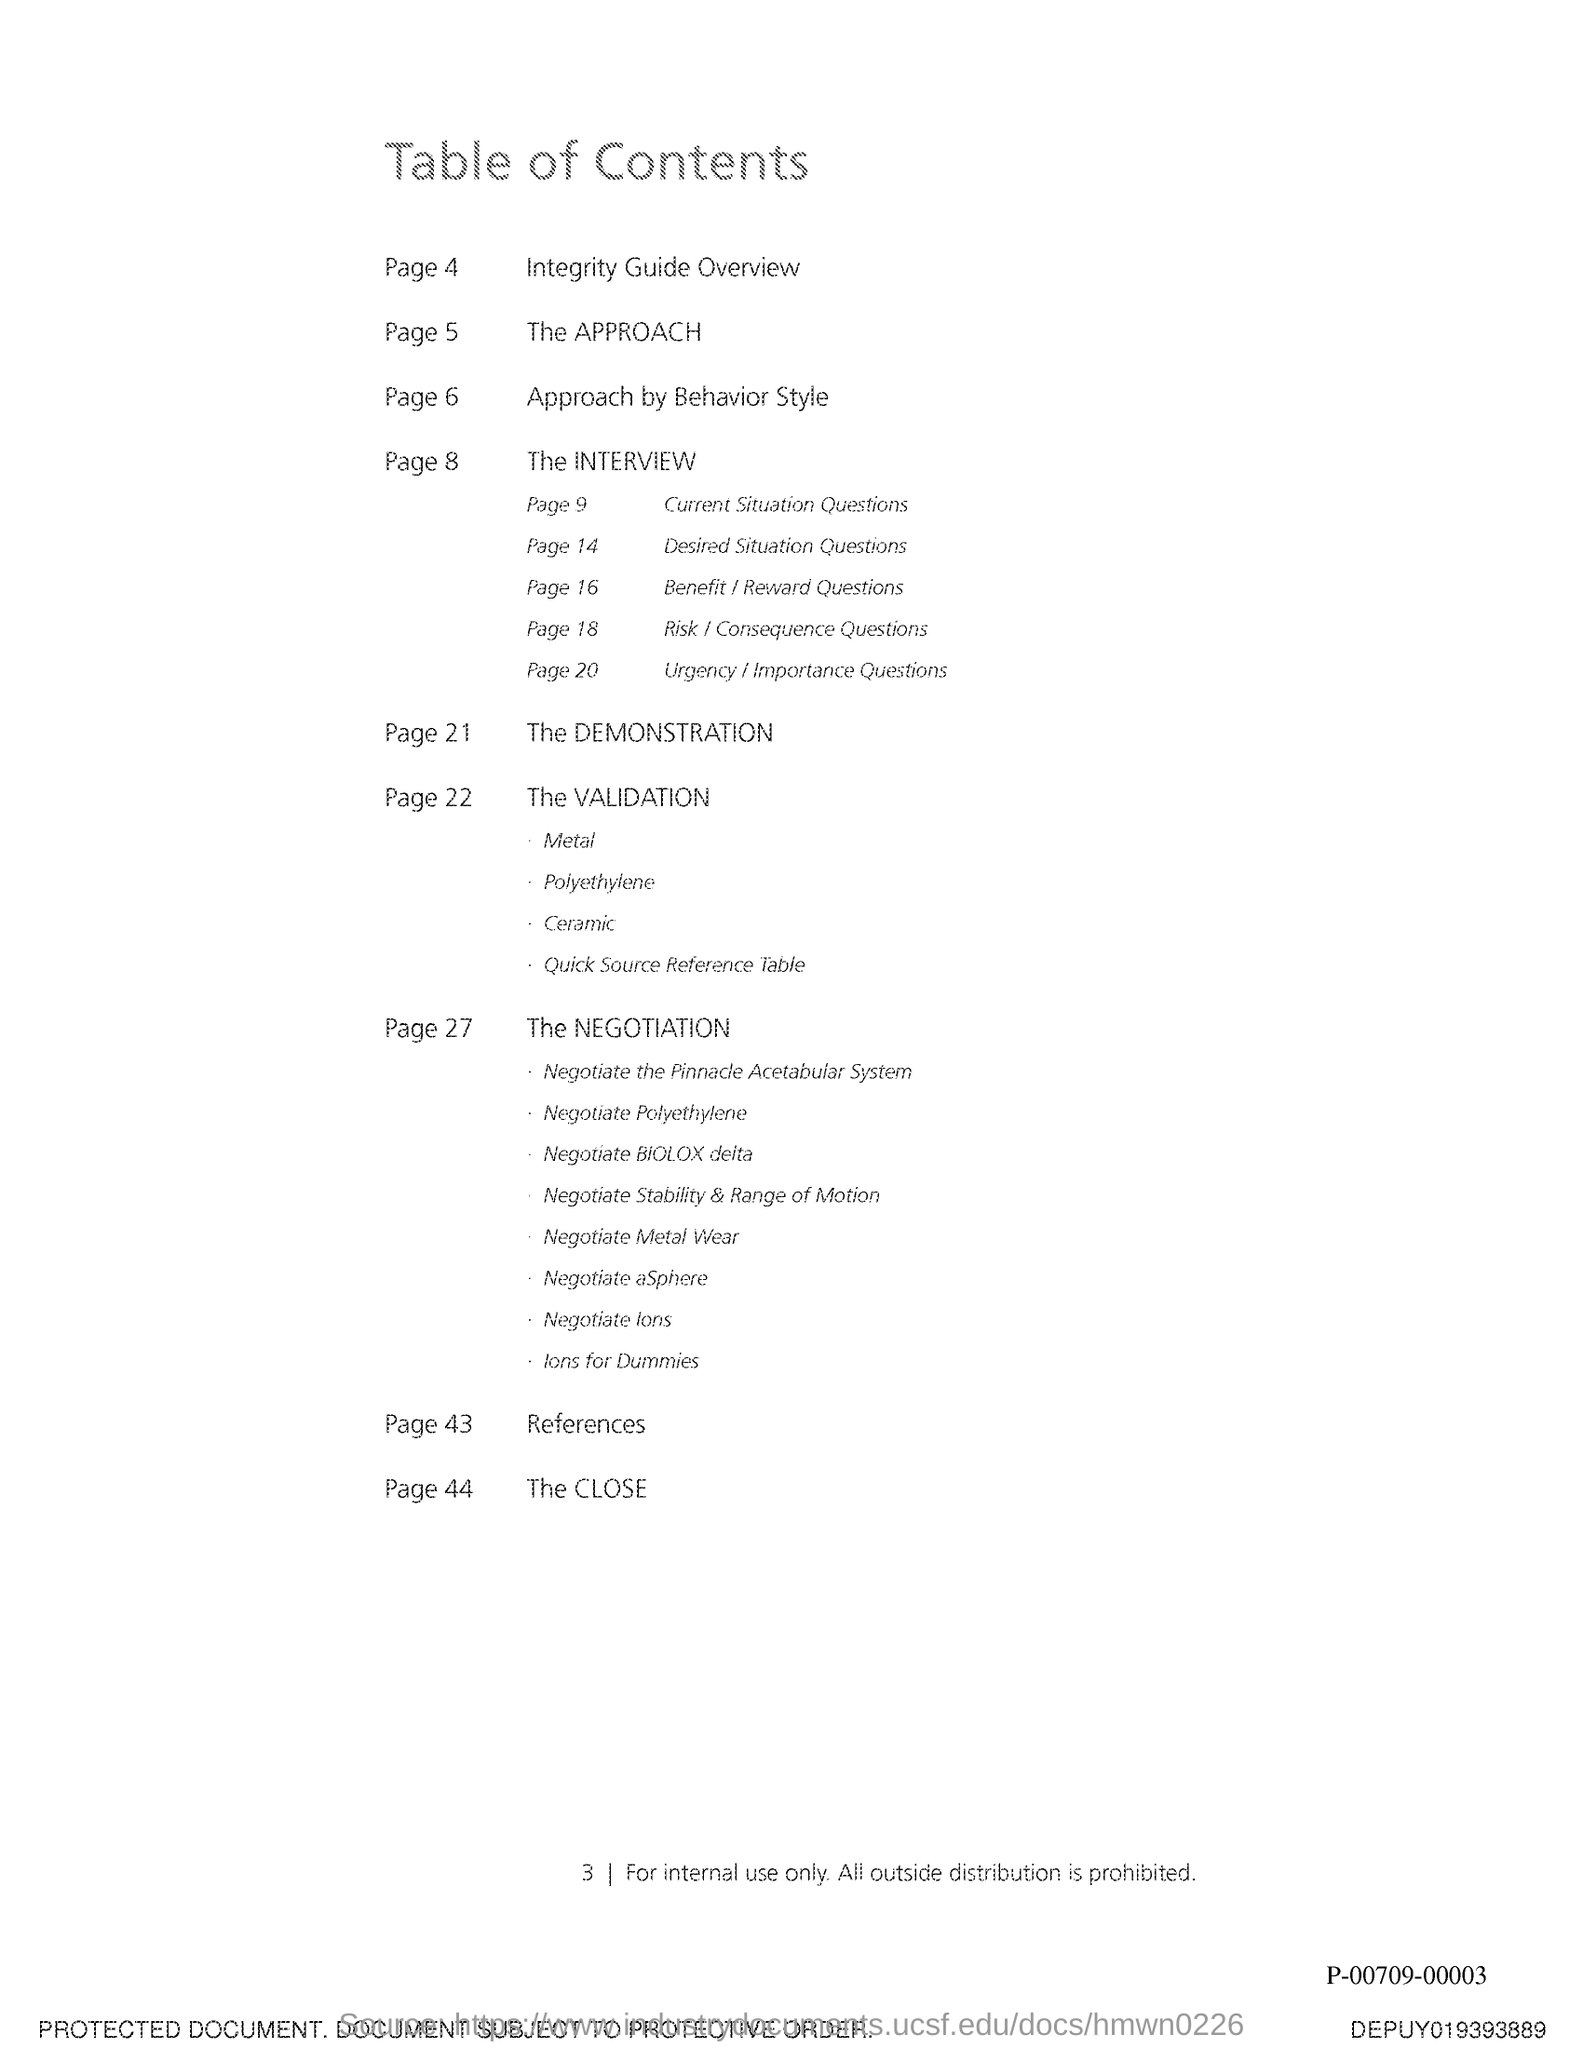What is the title of the document?
Your answer should be very brief. Table of Contents. The References is in which page?
Your answer should be very brief. Page 43. The Validation is in which page?
Ensure brevity in your answer.  Page 22. 